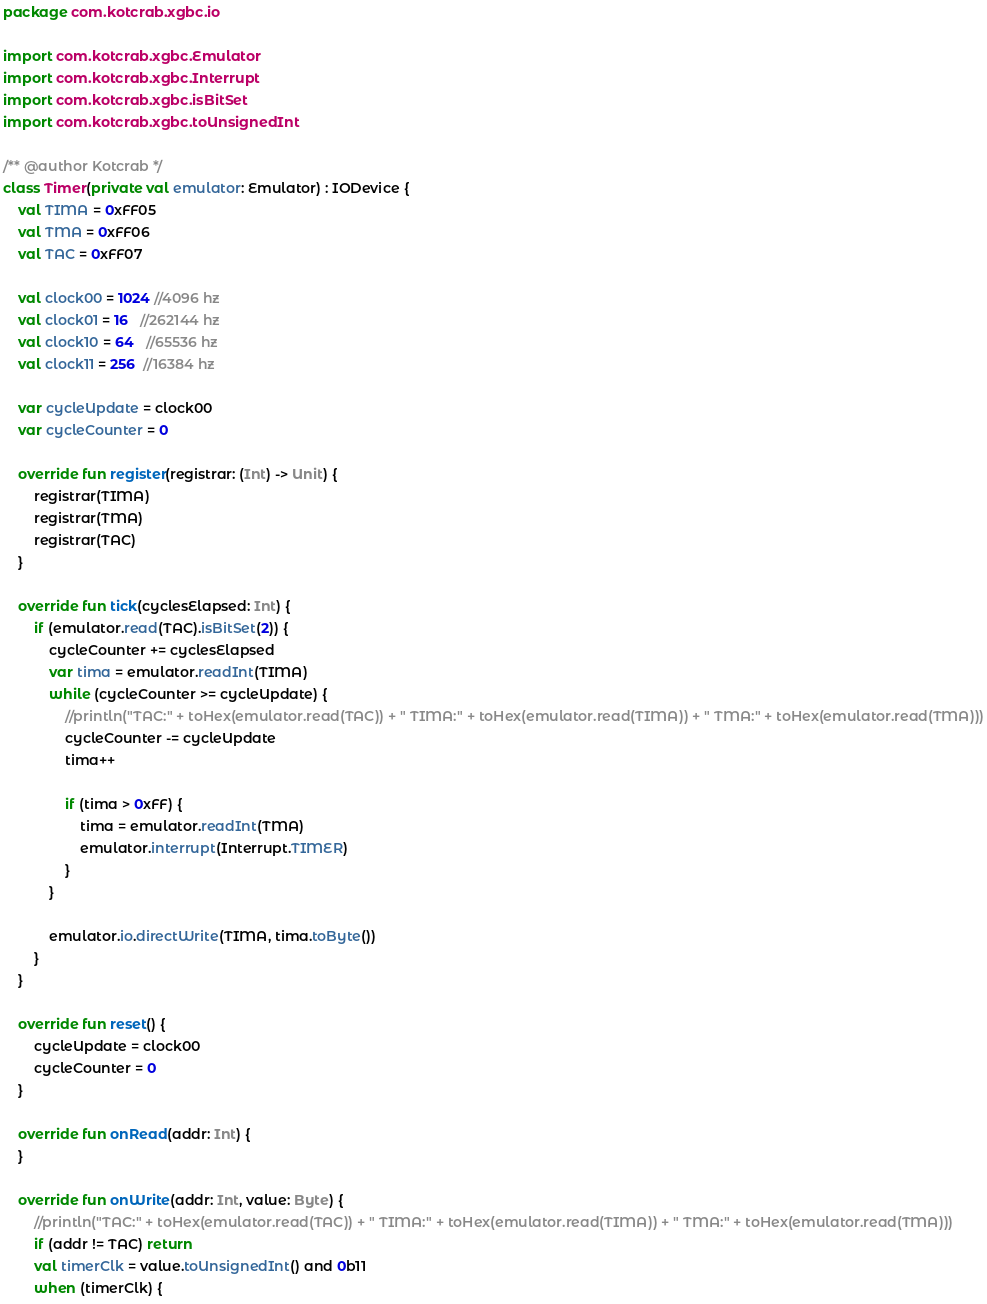<code> <loc_0><loc_0><loc_500><loc_500><_Kotlin_>package com.kotcrab.xgbc.io

import com.kotcrab.xgbc.Emulator
import com.kotcrab.xgbc.Interrupt
import com.kotcrab.xgbc.isBitSet
import com.kotcrab.xgbc.toUnsignedInt

/** @author Kotcrab */
class Timer(private val emulator: Emulator) : IODevice {
    val TIMA = 0xFF05
    val TMA = 0xFF06
    val TAC = 0xFF07

    val clock00 = 1024 //4096 hz
    val clock01 = 16   //262144 hz
    val clock10 = 64   //65536 hz
    val clock11 = 256  //16384 hz

    var cycleUpdate = clock00
    var cycleCounter = 0

    override fun register(registrar: (Int) -> Unit) {
        registrar(TIMA)
        registrar(TMA)
        registrar(TAC)
    }

    override fun tick(cyclesElapsed: Int) {
        if (emulator.read(TAC).isBitSet(2)) {
            cycleCounter += cyclesElapsed
            var tima = emulator.readInt(TIMA)
            while (cycleCounter >= cycleUpdate) {
                //println("TAC:" + toHex(emulator.read(TAC)) + " TIMA:" + toHex(emulator.read(TIMA)) + " TMA:" + toHex(emulator.read(TMA)))
                cycleCounter -= cycleUpdate
                tima++

                if (tima > 0xFF) {
                    tima = emulator.readInt(TMA)
                    emulator.interrupt(Interrupt.TIMER)
                }
            }

            emulator.io.directWrite(TIMA, tima.toByte())
        }
    }

    override fun reset() {
        cycleUpdate = clock00
        cycleCounter = 0
    }

    override fun onRead(addr: Int) {
    }

    override fun onWrite(addr: Int, value: Byte) {
        //println("TAC:" + toHex(emulator.read(TAC)) + " TIMA:" + toHex(emulator.read(TIMA)) + " TMA:" + toHex(emulator.read(TMA)))
        if (addr != TAC) return
        val timerClk = value.toUnsignedInt() and 0b11
        when (timerClk) {</code> 